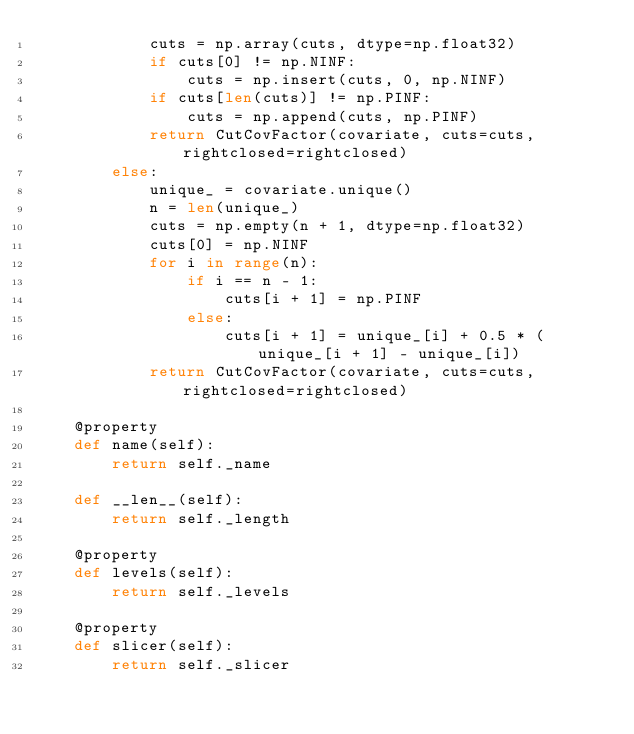<code> <loc_0><loc_0><loc_500><loc_500><_Python_>            cuts = np.array(cuts, dtype=np.float32)
            if cuts[0] != np.NINF:
                cuts = np.insert(cuts, 0, np.NINF)
            if cuts[len(cuts)] != np.PINF:
                cuts = np.append(cuts, np.PINF)
            return CutCovFactor(covariate, cuts=cuts, rightclosed=rightclosed)
        else:
            unique_ = covariate.unique()
            n = len(unique_)
            cuts = np.empty(n + 1, dtype=np.float32)
            cuts[0] = np.NINF
            for i in range(n):
                if i == n - 1:
                    cuts[i + 1] = np.PINF
                else:
                    cuts[i + 1] = unique_[i] + 0.5 * (unique_[i + 1] - unique_[i])
            return CutCovFactor(covariate, cuts=cuts, rightclosed=rightclosed)

    @property
    def name(self):
        return self._name

    def __len__(self):
        return self._length

    @property
    def levels(self):
        return self._levels

    @property
    def slicer(self):
        return self._slicer

    </code> 